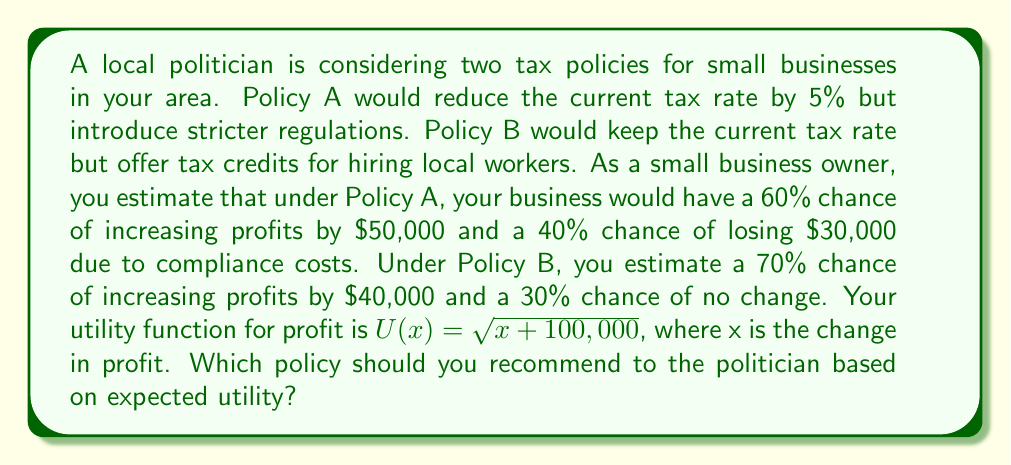Teach me how to tackle this problem. To solve this problem, we need to calculate the expected utility for each policy and compare them:

1. Calculate the expected utility for Policy A:
   $$E[U(A)] = 0.6 \cdot U(50,000) + 0.4 \cdot U(-30,000)$$
   $$U(50,000) = \sqrt{50,000 + 100,000} = \sqrt{150,000} \approx 387.30$$
   $$U(-30,000) = \sqrt{-30,000 + 100,000} = \sqrt{70,000} \approx 264.58$$
   $$E[U(A)] = 0.6 \cdot 387.30 + 0.4 \cdot 264.58 = 232.38 + 105.83 = 338.21$$

2. Calculate the expected utility for Policy B:
   $$E[U(B)] = 0.7 \cdot U(40,000) + 0.3 \cdot U(0)$$
   $$U(40,000) = \sqrt{40,000 + 100,000} = \sqrt{140,000} \approx 374.17$$
   $$U(0) = \sqrt{0 + 100,000} = \sqrt{100,000} = 316.23$$
   $$E[U(B)] = 0.7 \cdot 374.17 + 0.3 \cdot 316.23 = 261.92 + 94.87 = 356.79$$

3. Compare the expected utilities:
   Policy A: 338.21
   Policy B: 356.79

Since the expected utility of Policy B (356.79) is higher than that of Policy A (338.21), you should recommend Policy B to the politician based on expected utility.
Answer: Recommend Policy B to the politician, as it has a higher expected utility of 356.79 compared to Policy A's expected utility of 338.21. 